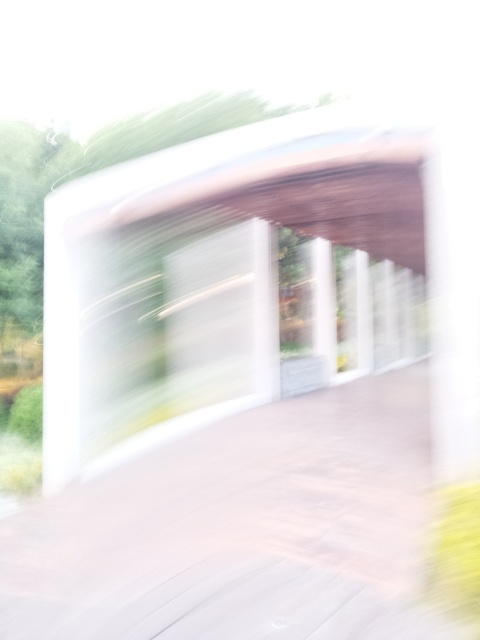Is there any way this image could be utilized despite its poor quality? While the image's quality is poor regarding clarity and detail, it can still be utilized creatively. It could serve as a background for a graphic design project, be used to convey a sense of motion or confusion, or even evoke a particular mood or atmosphere within an artistic composition. Additionally, with the right context or caption, it could contribute to abstract or experimental photography collections. 